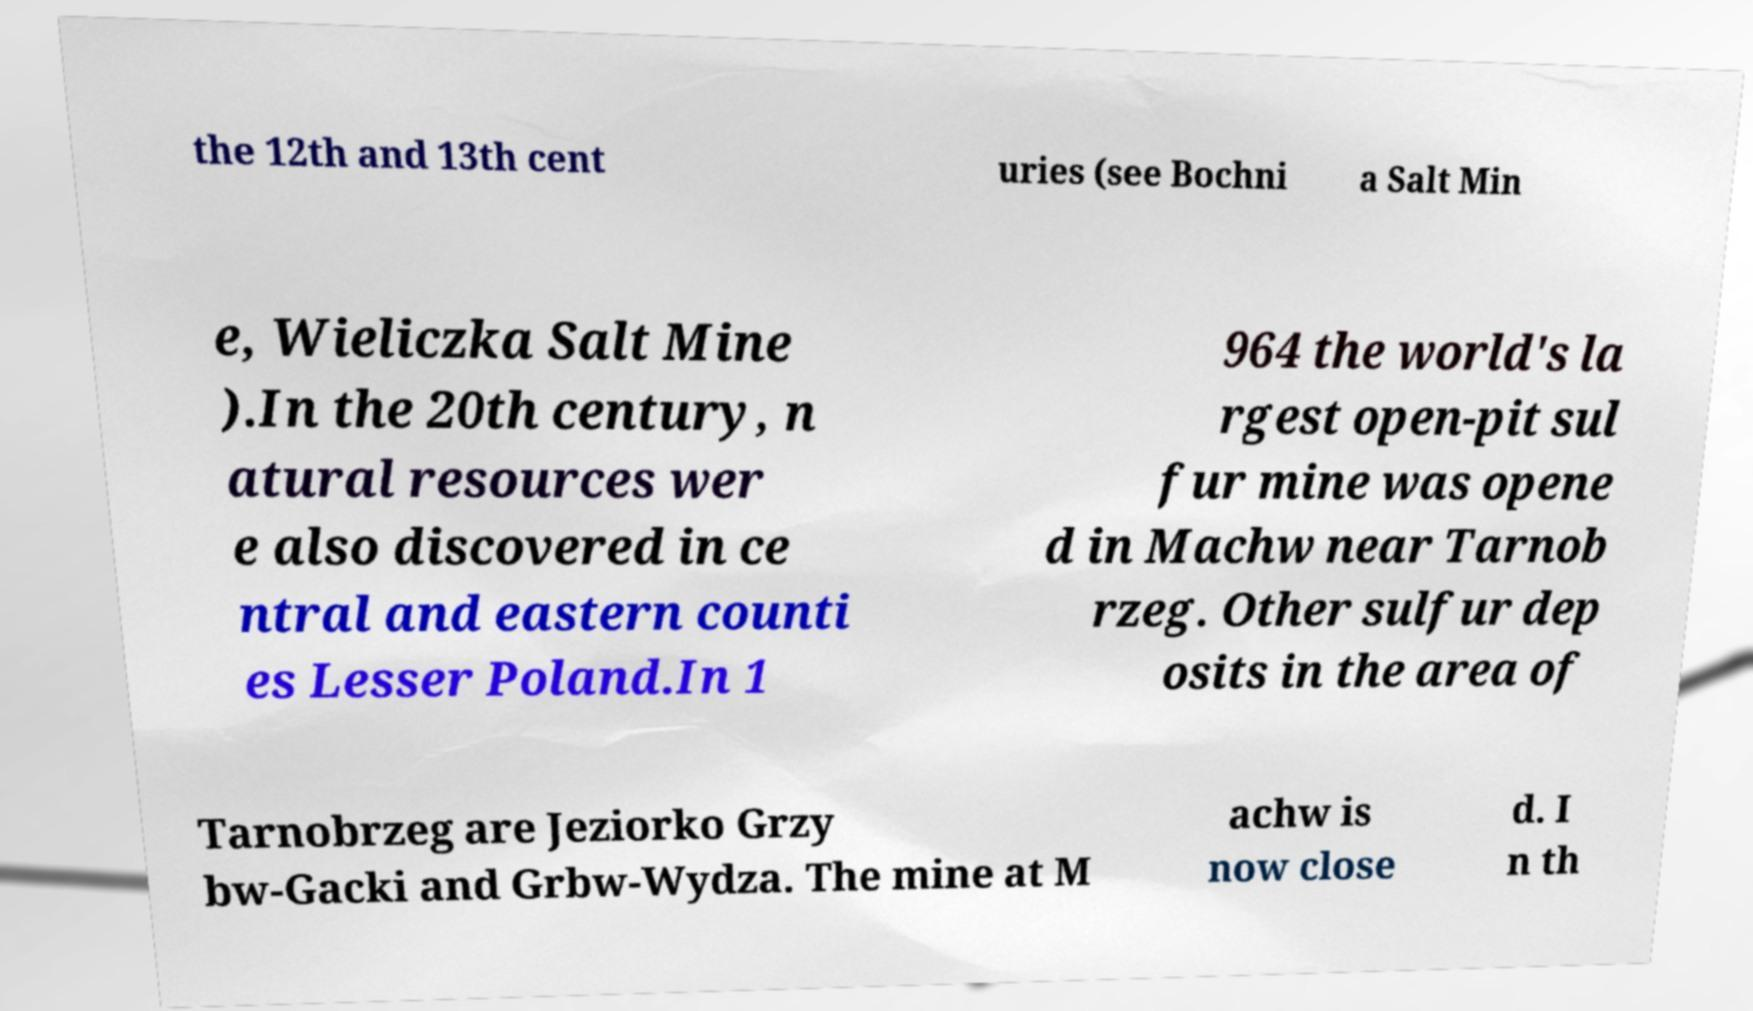Please identify and transcribe the text found in this image. the 12th and 13th cent uries (see Bochni a Salt Min e, Wieliczka Salt Mine ).In the 20th century, n atural resources wer e also discovered in ce ntral and eastern counti es Lesser Poland.In 1 964 the world's la rgest open-pit sul fur mine was opene d in Machw near Tarnob rzeg. Other sulfur dep osits in the area of Tarnobrzeg are Jeziorko Grzy bw-Gacki and Grbw-Wydza. The mine at M achw is now close d. I n th 